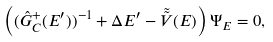<formula> <loc_0><loc_0><loc_500><loc_500>\left ( ( \hat { G } ^ { + } _ { C } ( E ^ { \prime } ) ) ^ { - 1 } + \Delta E ^ { \prime } - \tilde { \tilde { V } } ( E ) \right ) \Psi _ { E } = 0 ,</formula> 